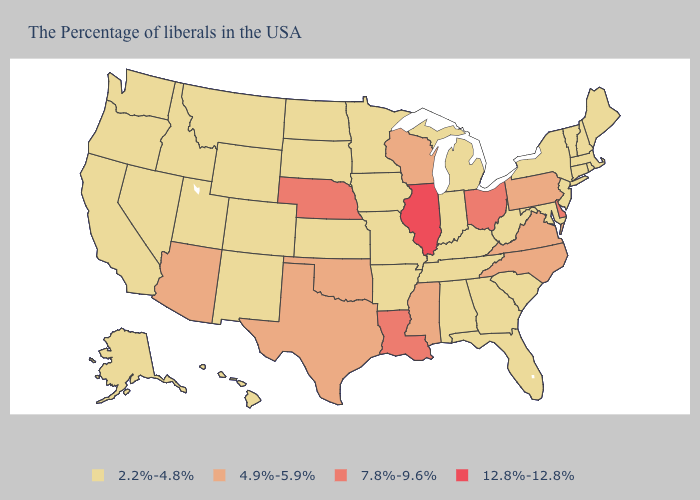Among the states that border Wisconsin , does Minnesota have the lowest value?
Give a very brief answer. Yes. What is the highest value in the West ?
Short answer required. 4.9%-5.9%. Name the states that have a value in the range 4.9%-5.9%?
Write a very short answer. Pennsylvania, Virginia, North Carolina, Wisconsin, Mississippi, Oklahoma, Texas, Arizona. Does Montana have the lowest value in the USA?
Give a very brief answer. Yes. Does the first symbol in the legend represent the smallest category?
Answer briefly. Yes. What is the value of Pennsylvania?
Quick response, please. 4.9%-5.9%. Among the states that border Utah , does Nevada have the lowest value?
Concise answer only. Yes. Name the states that have a value in the range 12.8%-12.8%?
Answer briefly. Illinois. What is the value of Arizona?
Keep it brief. 4.9%-5.9%. Among the states that border Connecticut , which have the lowest value?
Concise answer only. Massachusetts, Rhode Island, New York. What is the lowest value in the USA?
Keep it brief. 2.2%-4.8%. Is the legend a continuous bar?
Be succinct. No. What is the value of California?
Give a very brief answer. 2.2%-4.8%. What is the value of Delaware?
Quick response, please. 7.8%-9.6%. Name the states that have a value in the range 7.8%-9.6%?
Be succinct. Delaware, Ohio, Louisiana, Nebraska. 